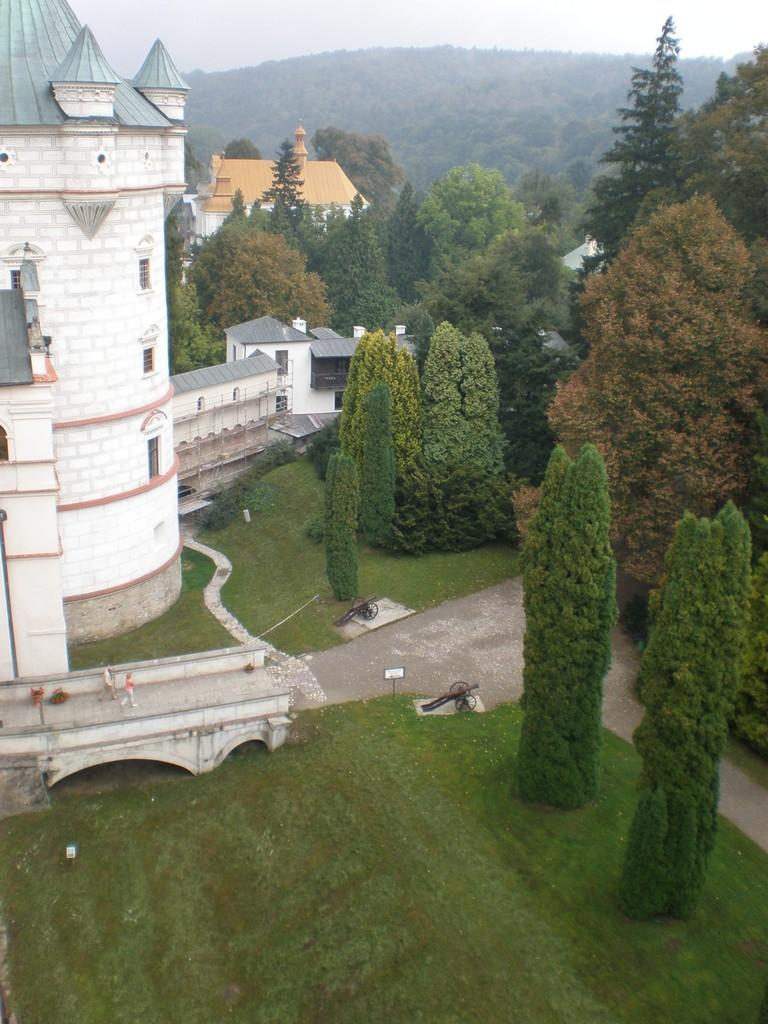What type of structures can be seen in the image? There are buildings in the image. What are the people in the image doing? There are persons walking on the floor in the image. What type of vehicles are present in the image? There are carts in the image. What type of vegetation can be seen in the image? There are trees and bushes in the image. What part of the natural environment is visible in the image? The ground and the sky are visible in the image. What time of day is depicted in the image, and how does it affect the visibility of the scene? The time of day is not mentioned in the image, and the visibility of the scene is not affected by the time of day. Additionally, there is no specific "scene" being depicted in the image. 